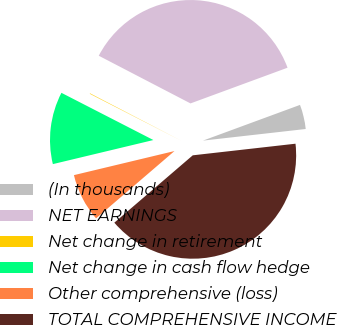Convert chart. <chart><loc_0><loc_0><loc_500><loc_500><pie_chart><fcel>(In thousands)<fcel>NET EARNINGS<fcel>Net change in retirement<fcel>Net change in cash flow hedge<fcel>Other comprehensive (loss)<fcel>TOTAL COMPREHENSIVE INCOME<nl><fcel>3.82%<fcel>36.76%<fcel>0.08%<fcel>11.29%<fcel>7.55%<fcel>40.5%<nl></chart> 